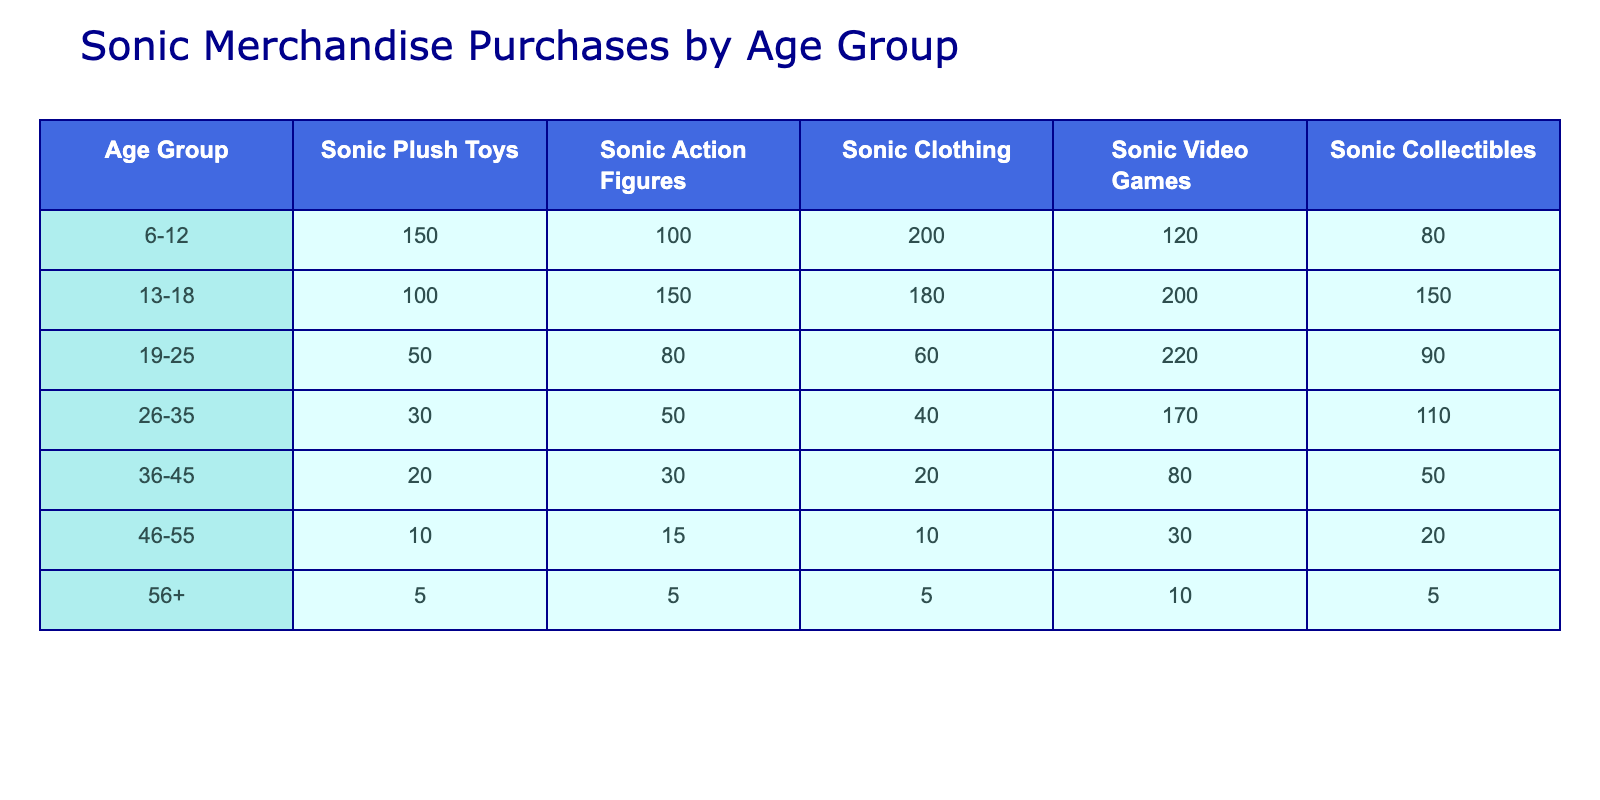What age group purchased the most Sonic video games? Looking at the Sonic video games column, the age group 19-25 has the highest value with 220 purchases.
Answer: 19-25 Which merchandise type is most popular among the 6-12 age group? In the 6-12 age group, Sonic clothing has the highest number of purchases at 200, compared to other merchandise types.
Answer: Sonic Clothing What is the total number of Sonic collectibles purchased across all age groups? To find the total, add up all values in the Sonic collectibles column: 80 + 150 + 90 + 110 + 50 + 20 + 5 = 505.
Answer: 505 Is the number of Sonic action figures purchased by the 26-35 age group greater than the number purchased by the 36-45 age group? For the 26-35 age group, 50 Sonic action figures were purchased, while for the 36-45 age group, 30 were purchased. Since 50 is greater than 30, the statement is true.
Answer: Yes Which age group collectively bought less than 100 Sonic plush toys? The age groups 46-55 and 56+ both bought less than 100 Sonic plush toys, with 10 and 5 purchases respectively.
Answer: 46-55 and 56+ What is the average number of Sonic clothing items purchased by the 19-25 and 26-35 age groups? For age group 19-25, 60 Sonic clothing items were purchased. For 26-35, 40 items were purchased. The average is (60 + 40) / 2 = 50.
Answer: 50 Did the 13-18 age group purchase more Sonic collectibles than the 46-55 age group? The 13-18 age group purchased 150 collectibles, while the 46-55 age group purchased only 20 collectibles. Since 150 is greater than 20, the statement is true.
Answer: Yes What percentage of total Sonic action figures purchased were from the age group 13-18? First, total the action figures: 100 + 150 + 80 + 50 + 30 + 15 + 5 = 430. The 13-18 age group bought 150. The percentage is (150 / 430) * 100 ≈ 34.88%.
Answer: 34.88% What is the difference in the number of Sonic video games purchased between the 19-25 and 26-35 age groups? The 19-25 age group purchased 220 Sonic video games, and the 26-35 age group purchased 170. The difference is 220 - 170 = 50.
Answer: 50 